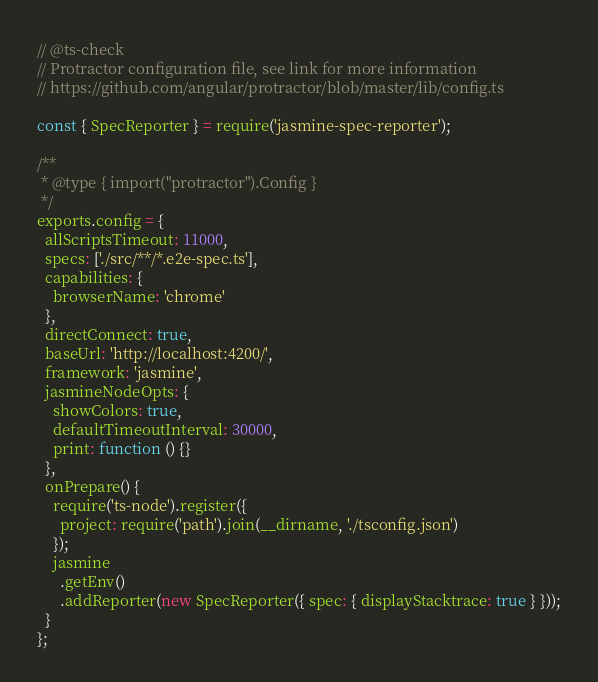Convert code to text. <code><loc_0><loc_0><loc_500><loc_500><_JavaScript_>// @ts-check
// Protractor configuration file, see link for more information
// https://github.com/angular/protractor/blob/master/lib/config.ts

const { SpecReporter } = require('jasmine-spec-reporter');

/**
 * @type { import("protractor").Config }
 */
exports.config = {
  allScriptsTimeout: 11000,
  specs: ['./src/**/*.e2e-spec.ts'],
  capabilities: {
    browserName: 'chrome'
  },
  directConnect: true,
  baseUrl: 'http://localhost:4200/',
  framework: 'jasmine',
  jasmineNodeOpts: {
    showColors: true,
    defaultTimeoutInterval: 30000,
    print: function () {}
  },
  onPrepare() {
    require('ts-node').register({
      project: require('path').join(__dirname, './tsconfig.json')
    });
    jasmine
      .getEnv()
      .addReporter(new SpecReporter({ spec: { displayStacktrace: true } }));
  }
};
</code> 